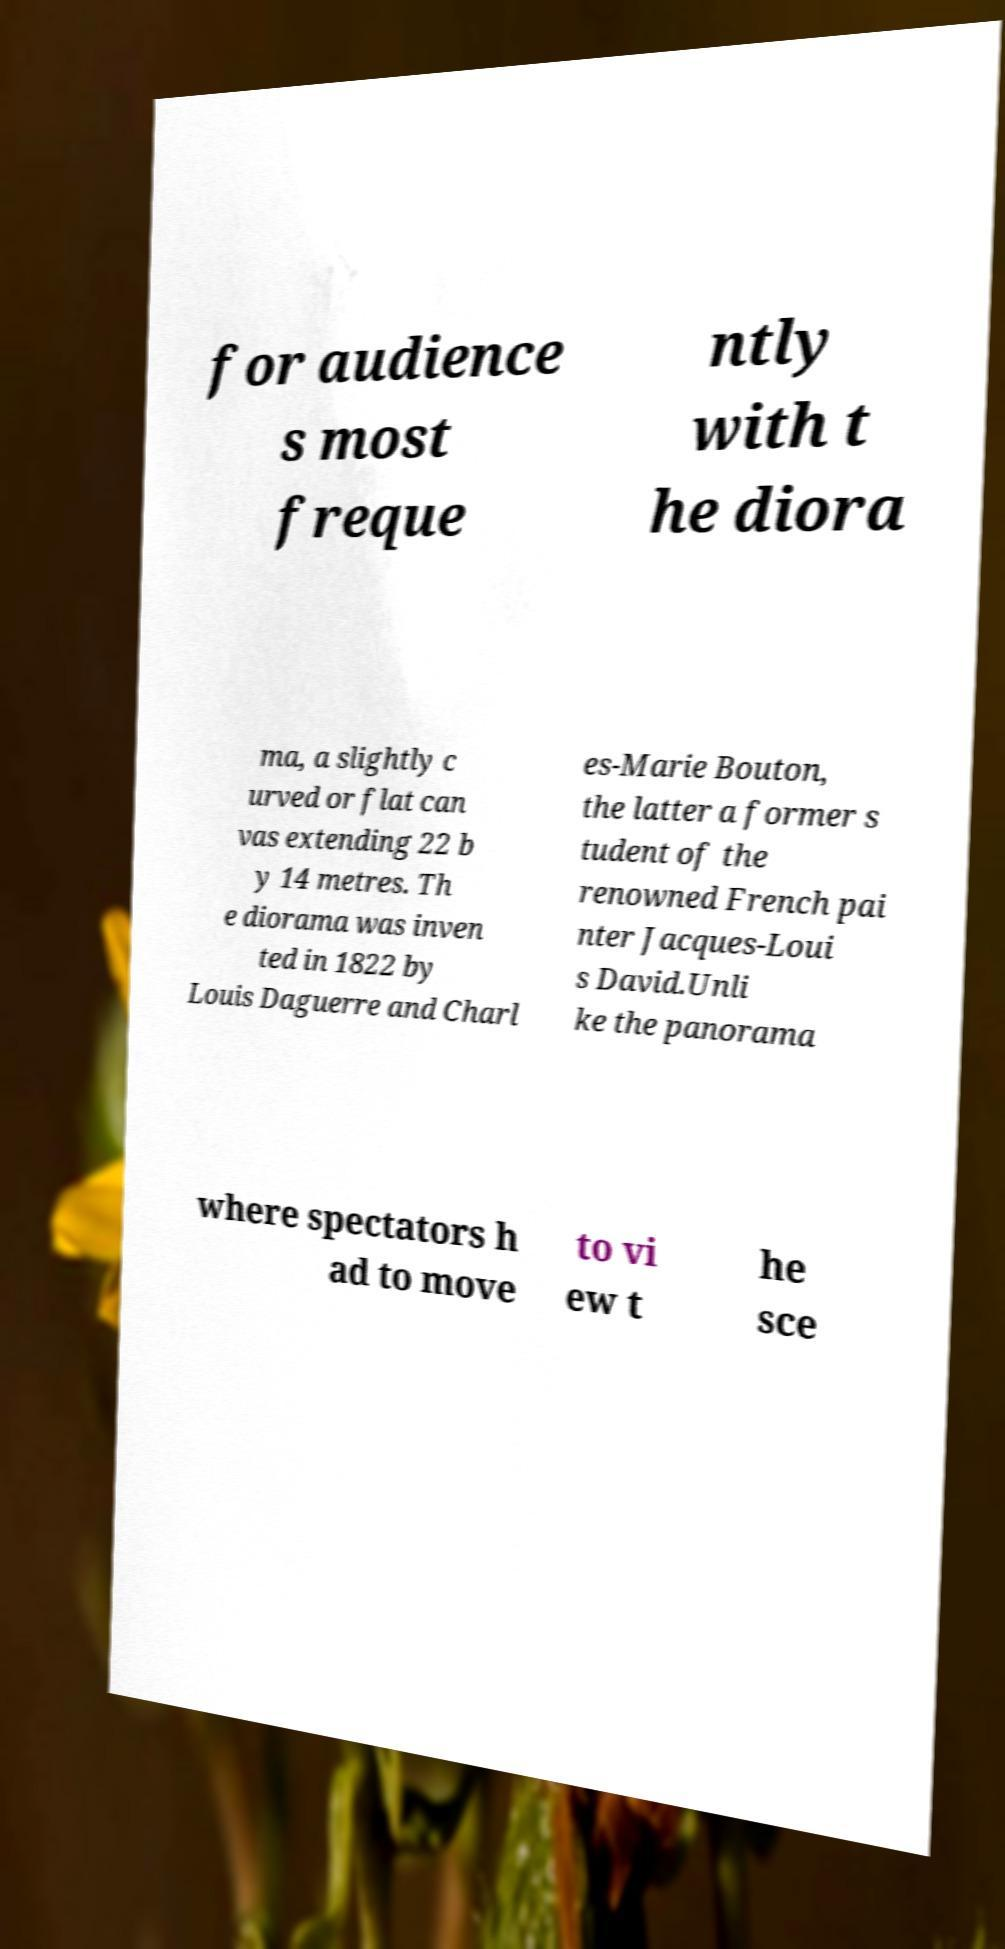Please identify and transcribe the text found in this image. for audience s most freque ntly with t he diora ma, a slightly c urved or flat can vas extending 22 b y 14 metres. Th e diorama was inven ted in 1822 by Louis Daguerre and Charl es-Marie Bouton, the latter a former s tudent of the renowned French pai nter Jacques-Loui s David.Unli ke the panorama where spectators h ad to move to vi ew t he sce 